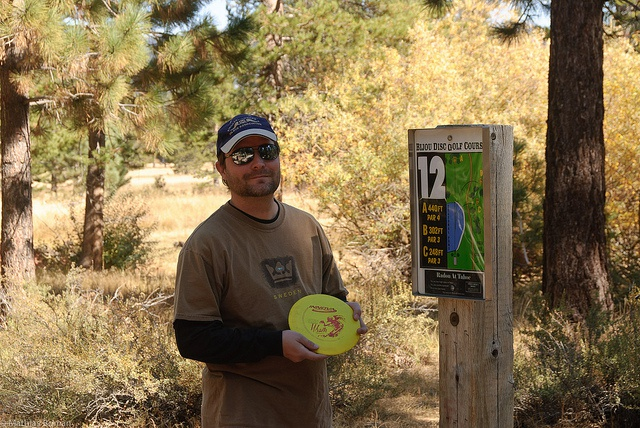Describe the objects in this image and their specific colors. I can see people in tan, black, maroon, and gray tones and frisbee in tan and olive tones in this image. 